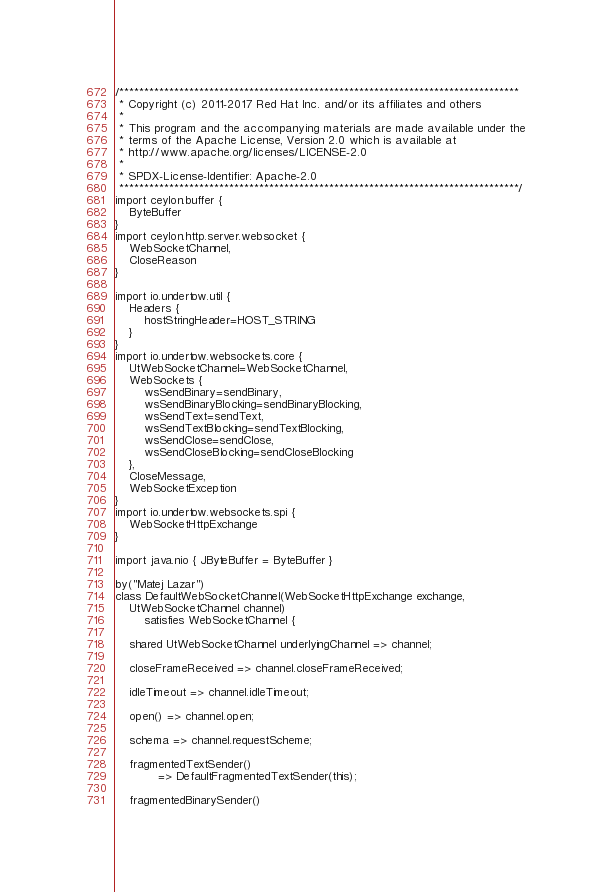Convert code to text. <code><loc_0><loc_0><loc_500><loc_500><_Ceylon_>/********************************************************************************
 * Copyright (c) 2011-2017 Red Hat Inc. and/or its affiliates and others
 *
 * This program and the accompanying materials are made available under the 
 * terms of the Apache License, Version 2.0 which is available at
 * http://www.apache.org/licenses/LICENSE-2.0
 *
 * SPDX-License-Identifier: Apache-2.0 
 ********************************************************************************/
import ceylon.buffer {
    ByteBuffer
}
import ceylon.http.server.websocket {
    WebSocketChannel,
    CloseReason
}

import io.undertow.util {
    Headers {
        hostStringHeader=HOST_STRING
    }
}
import io.undertow.websockets.core {
    UtWebSocketChannel=WebSocketChannel,
    WebSockets {
        wsSendBinary=sendBinary,
        wsSendBinaryBlocking=sendBinaryBlocking,
        wsSendText=sendText,
        wsSendTextBlocking=sendTextBlocking,
        wsSendClose=sendClose,
        wsSendCloseBlocking=sendCloseBlocking
    },
    CloseMessage,
    WebSocketException
}
import io.undertow.websockets.spi {
    WebSocketHttpExchange
}

import java.nio { JByteBuffer = ByteBuffer }

by("Matej Lazar")
class DefaultWebSocketChannel(WebSocketHttpExchange exchange, 
    UtWebSocketChannel channel) 
        satisfies WebSocketChannel {

    shared UtWebSocketChannel underlyingChannel => channel;

    closeFrameReceived => channel.closeFrameReceived;

    idleTimeout => channel.idleTimeout;

    open() => channel.open;

    schema => channel.requestScheme;

    fragmentedTextSender() 
            => DefaultFragmentedTextSender(this);

    fragmentedBinarySender() </code> 